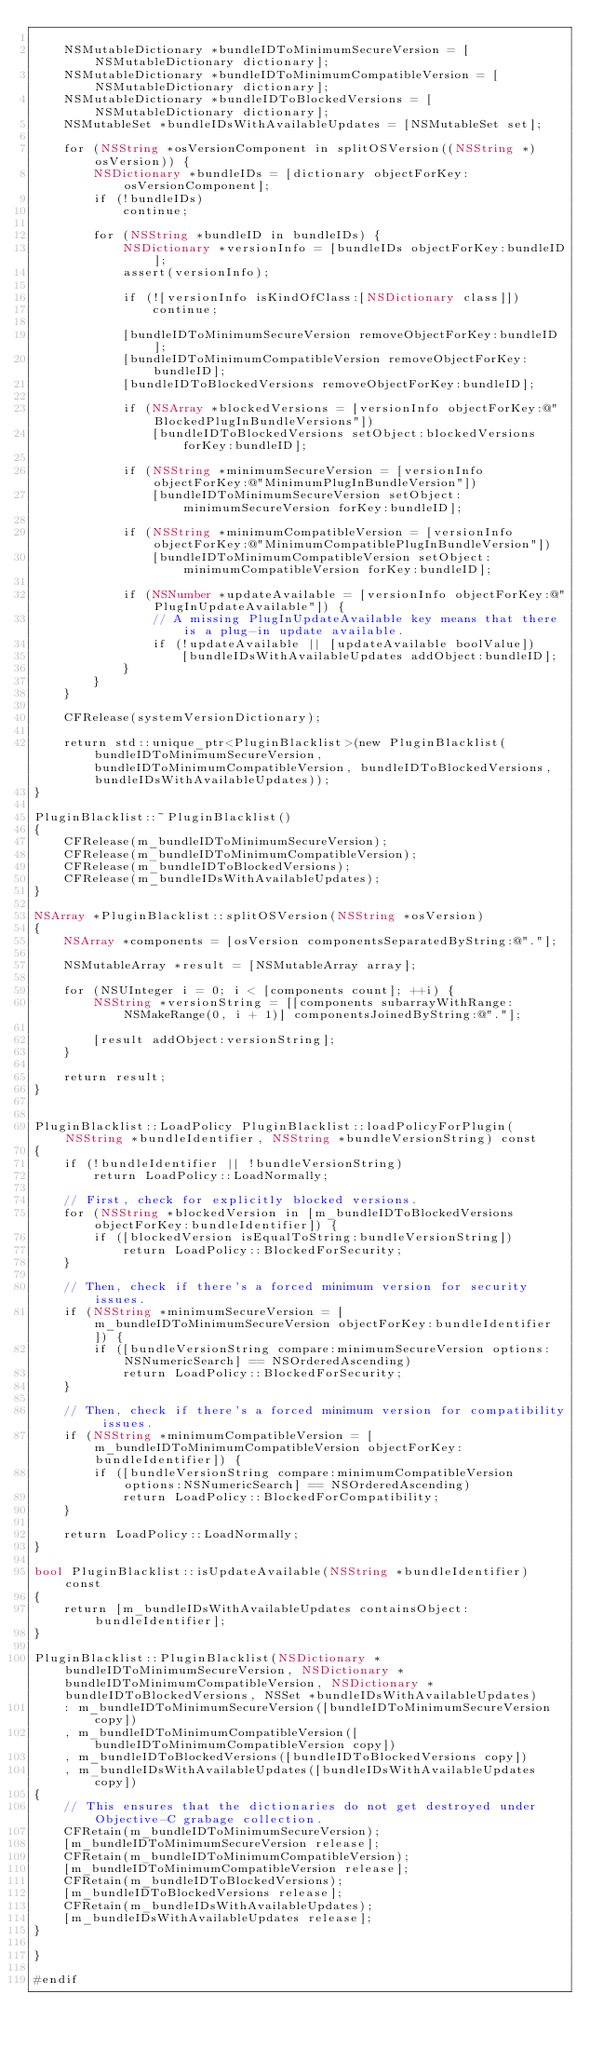<code> <loc_0><loc_0><loc_500><loc_500><_ObjectiveC_>
    NSMutableDictionary *bundleIDToMinimumSecureVersion = [NSMutableDictionary dictionary];
    NSMutableDictionary *bundleIDToMinimumCompatibleVersion = [NSMutableDictionary dictionary];
    NSMutableDictionary *bundleIDToBlockedVersions = [NSMutableDictionary dictionary];
    NSMutableSet *bundleIDsWithAvailableUpdates = [NSMutableSet set];
    
    for (NSString *osVersionComponent in splitOSVersion((NSString *)osVersion)) {
        NSDictionary *bundleIDs = [dictionary objectForKey:osVersionComponent];
        if (!bundleIDs)
            continue;

        for (NSString *bundleID in bundleIDs) {
            NSDictionary *versionInfo = [bundleIDs objectForKey:bundleID];
            assert(versionInfo);

            if (![versionInfo isKindOfClass:[NSDictionary class]])
                continue;

            [bundleIDToMinimumSecureVersion removeObjectForKey:bundleID];
            [bundleIDToMinimumCompatibleVersion removeObjectForKey:bundleID];
            [bundleIDToBlockedVersions removeObjectForKey:bundleID];

            if (NSArray *blockedVersions = [versionInfo objectForKey:@"BlockedPlugInBundleVersions"])
                [bundleIDToBlockedVersions setObject:blockedVersions forKey:bundleID];

            if (NSString *minimumSecureVersion = [versionInfo objectForKey:@"MinimumPlugInBundleVersion"])
                [bundleIDToMinimumSecureVersion setObject:minimumSecureVersion forKey:bundleID];

            if (NSString *minimumCompatibleVersion = [versionInfo objectForKey:@"MinimumCompatiblePlugInBundleVersion"])
                [bundleIDToMinimumCompatibleVersion setObject:minimumCompatibleVersion forKey:bundleID];

            if (NSNumber *updateAvailable = [versionInfo objectForKey:@"PlugInUpdateAvailable"]) {
                // A missing PlugInUpdateAvailable key means that there is a plug-in update available.
                if (!updateAvailable || [updateAvailable boolValue])
                    [bundleIDsWithAvailableUpdates addObject:bundleID];
            }
        }
    }

    CFRelease(systemVersionDictionary);

    return std::unique_ptr<PluginBlacklist>(new PluginBlacklist(bundleIDToMinimumSecureVersion, bundleIDToMinimumCompatibleVersion, bundleIDToBlockedVersions, bundleIDsWithAvailableUpdates));
}

PluginBlacklist::~PluginBlacklist()
{
    CFRelease(m_bundleIDToMinimumSecureVersion);
    CFRelease(m_bundleIDToMinimumCompatibleVersion);
    CFRelease(m_bundleIDToBlockedVersions);
    CFRelease(m_bundleIDsWithAvailableUpdates);
}

NSArray *PluginBlacklist::splitOSVersion(NSString *osVersion)
{
    NSArray *components = [osVersion componentsSeparatedByString:@"."];

    NSMutableArray *result = [NSMutableArray array];

    for (NSUInteger i = 0; i < [components count]; ++i) {
        NSString *versionString = [[components subarrayWithRange:NSMakeRange(0, i + 1)] componentsJoinedByString:@"."];

        [result addObject:versionString];
    }

    return result;
}


PluginBlacklist::LoadPolicy PluginBlacklist::loadPolicyForPlugin(NSString *bundleIdentifier, NSString *bundleVersionString) const
{
    if (!bundleIdentifier || !bundleVersionString)
        return LoadPolicy::LoadNormally;

    // First, check for explicitly blocked versions.
    for (NSString *blockedVersion in [m_bundleIDToBlockedVersions objectForKey:bundleIdentifier]) {
        if ([blockedVersion isEqualToString:bundleVersionString])
            return LoadPolicy::BlockedForSecurity;
    }

    // Then, check if there's a forced minimum version for security issues.
    if (NSString *minimumSecureVersion = [m_bundleIDToMinimumSecureVersion objectForKey:bundleIdentifier]) {
        if ([bundleVersionString compare:minimumSecureVersion options:NSNumericSearch] == NSOrderedAscending)
            return LoadPolicy::BlockedForSecurity;
    }

    // Then, check if there's a forced minimum version for compatibility issues.
    if (NSString *minimumCompatibleVersion = [m_bundleIDToMinimumCompatibleVersion objectForKey:bundleIdentifier]) {
        if ([bundleVersionString compare:minimumCompatibleVersion options:NSNumericSearch] == NSOrderedAscending)
            return LoadPolicy::BlockedForCompatibility;
    }

    return LoadPolicy::LoadNormally;
}

bool PluginBlacklist::isUpdateAvailable(NSString *bundleIdentifier) const
{
    return [m_bundleIDsWithAvailableUpdates containsObject:bundleIdentifier];
}

PluginBlacklist::PluginBlacklist(NSDictionary *bundleIDToMinimumSecureVersion, NSDictionary *bundleIDToMinimumCompatibleVersion, NSDictionary *bundleIDToBlockedVersions, NSSet *bundleIDsWithAvailableUpdates)
    : m_bundleIDToMinimumSecureVersion([bundleIDToMinimumSecureVersion copy])
    , m_bundleIDToMinimumCompatibleVersion([bundleIDToMinimumCompatibleVersion copy])
    , m_bundleIDToBlockedVersions([bundleIDToBlockedVersions copy])
    , m_bundleIDsWithAvailableUpdates([bundleIDsWithAvailableUpdates copy])
{
    // This ensures that the dictionaries do not get destroyed under Objective-C grabage collection.
    CFRetain(m_bundleIDToMinimumSecureVersion);
    [m_bundleIDToMinimumSecureVersion release];
    CFRetain(m_bundleIDToMinimumCompatibleVersion);
    [m_bundleIDToMinimumCompatibleVersion release];
    CFRetain(m_bundleIDToBlockedVersions);
    [m_bundleIDToBlockedVersions release];
    CFRetain(m_bundleIDsWithAvailableUpdates);
    [m_bundleIDsWithAvailableUpdates release];
}

}

#endif
</code> 